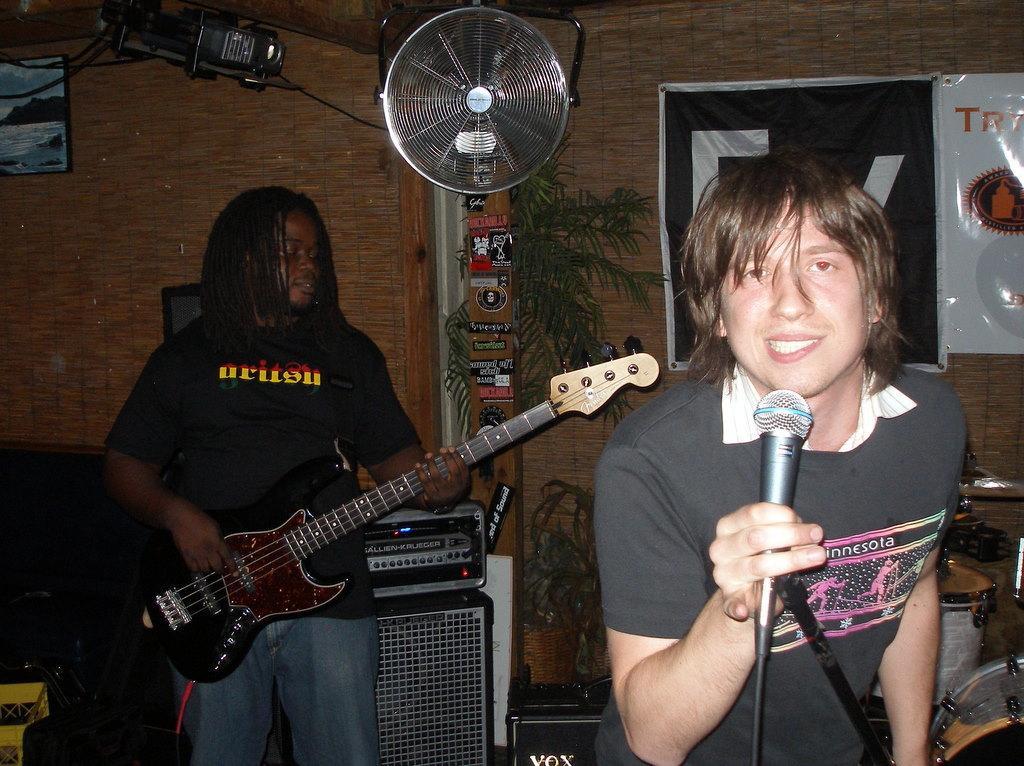How would you summarize this image in a sentence or two? In this image I can see a person wearing black color dress is standing and holding a microphone and another person wearing black t shirt and blue jeans is standing and holding a guitar in his hand. In the background I can see few musical instruments, few equipment, a fan, the brown colored wall, few wires, a photo frame attached to the wall, a tree and few banners. 